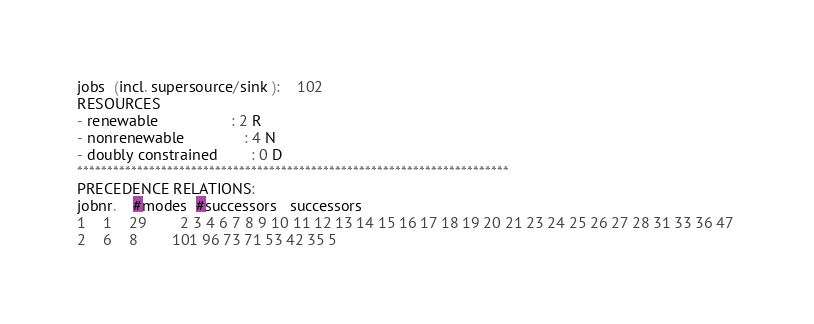Convert code to text. <code><loc_0><loc_0><loc_500><loc_500><_ObjectiveC_>jobs  (incl. supersource/sink ):	102
RESOURCES
- renewable                 : 2 R
- nonrenewable              : 4 N
- doubly constrained        : 0 D
************************************************************************
PRECEDENCE RELATIONS:
jobnr.    #modes  #successors   successors
1	1	29		2 3 4 6 7 8 9 10 11 12 13 14 15 16 17 18 19 20 21 23 24 25 26 27 28 31 33 36 47 
2	6	8		101 96 73 71 53 42 35 5 </code> 